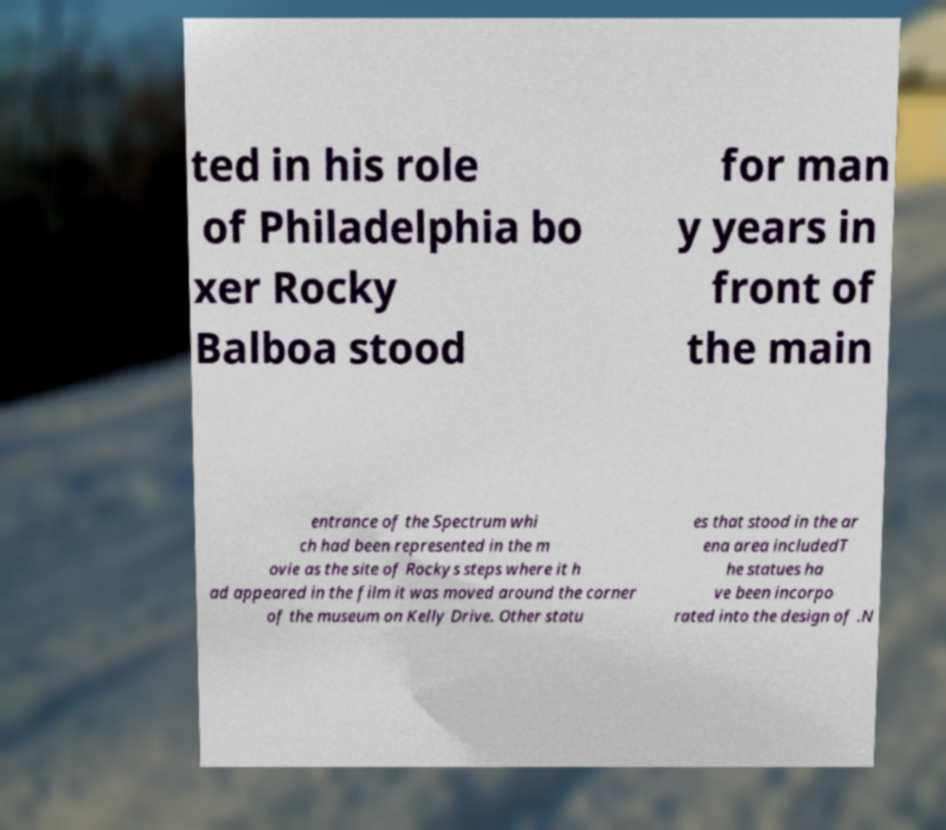Please identify and transcribe the text found in this image. ted in his role of Philadelphia bo xer Rocky Balboa stood for man y years in front of the main entrance of the Spectrum whi ch had been represented in the m ovie as the site of Rockys steps where it h ad appeared in the film it was moved around the corner of the museum on Kelly Drive. Other statu es that stood in the ar ena area includedT he statues ha ve been incorpo rated into the design of .N 